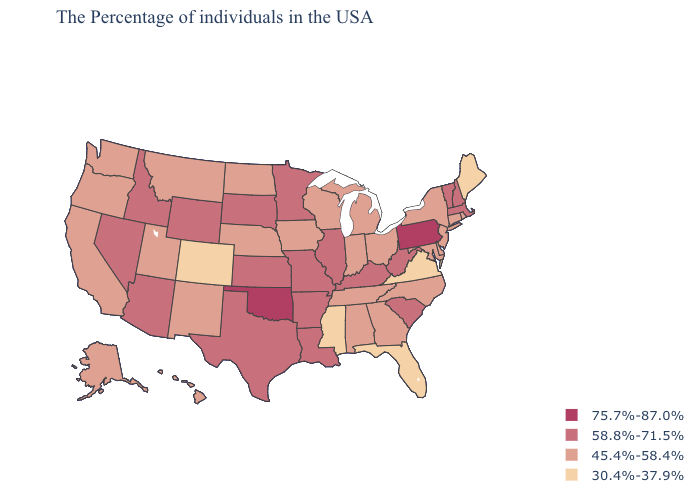Which states have the lowest value in the USA?
Answer briefly. Maine, Virginia, Florida, Mississippi, Colorado. Name the states that have a value in the range 30.4%-37.9%?
Quick response, please. Maine, Virginia, Florida, Mississippi, Colorado. Name the states that have a value in the range 45.4%-58.4%?
Concise answer only. Rhode Island, Connecticut, New York, New Jersey, Delaware, Maryland, North Carolina, Ohio, Georgia, Michigan, Indiana, Alabama, Tennessee, Wisconsin, Iowa, Nebraska, North Dakota, New Mexico, Utah, Montana, California, Washington, Oregon, Alaska, Hawaii. What is the highest value in the MidWest ?
Give a very brief answer. 58.8%-71.5%. Does the first symbol in the legend represent the smallest category?
Short answer required. No. Does South Dakota have the lowest value in the MidWest?
Quick response, please. No. Which states have the lowest value in the USA?
Give a very brief answer. Maine, Virginia, Florida, Mississippi, Colorado. What is the lowest value in the USA?
Concise answer only. 30.4%-37.9%. Among the states that border Maryland , which have the lowest value?
Short answer required. Virginia. What is the value of Ohio?
Give a very brief answer. 45.4%-58.4%. What is the value of Kentucky?
Answer briefly. 58.8%-71.5%. What is the lowest value in states that border South Carolina?
Write a very short answer. 45.4%-58.4%. Among the states that border New Hampshire , does Maine have the lowest value?
Answer briefly. Yes. Which states have the highest value in the USA?
Short answer required. Pennsylvania, Oklahoma. 